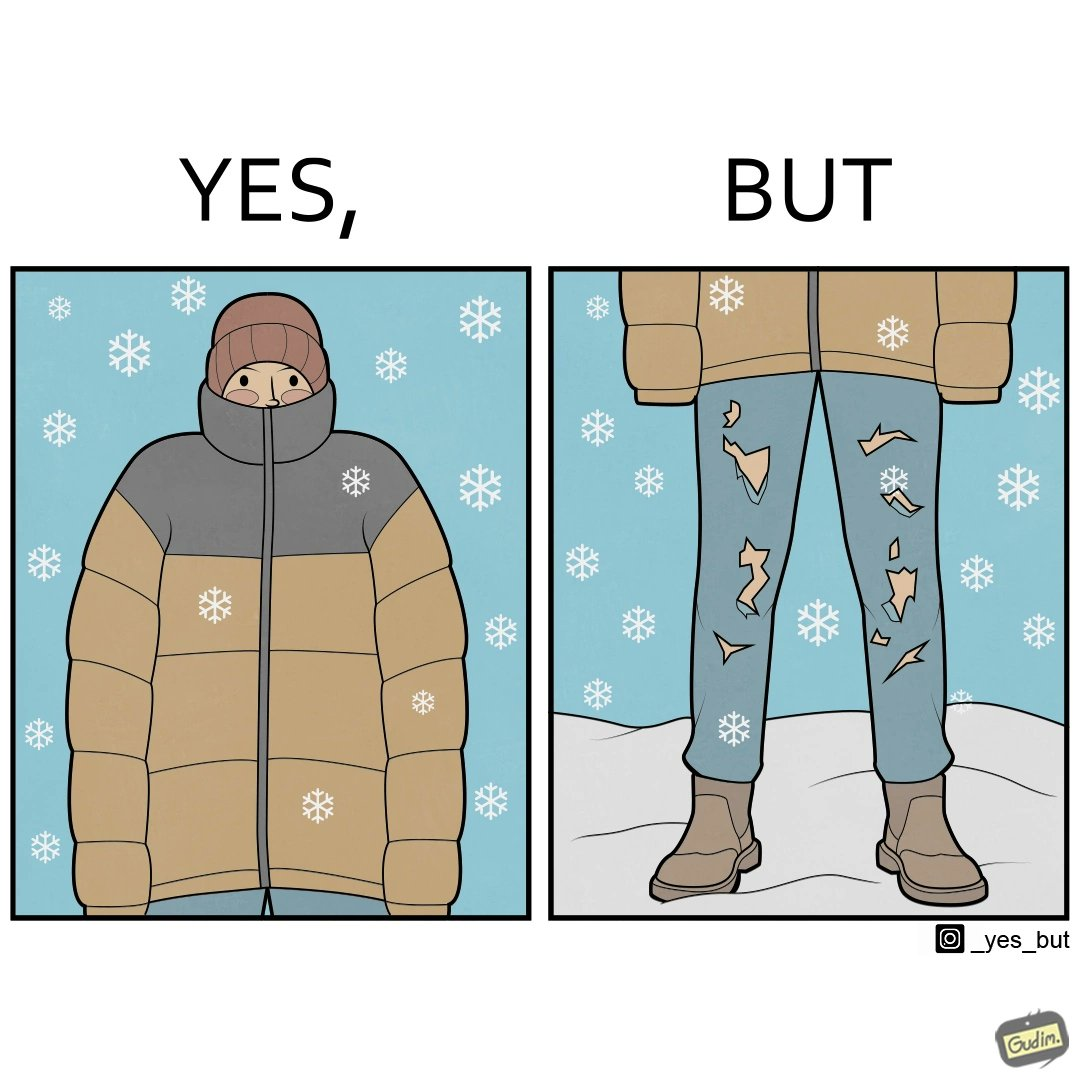Describe what you see in this image. This is funny because on the one hand this person is feeling very cold and has his jacket all the way up to his face, but on the other hand his trousers are torn which kind of makes the jacket redundant. 